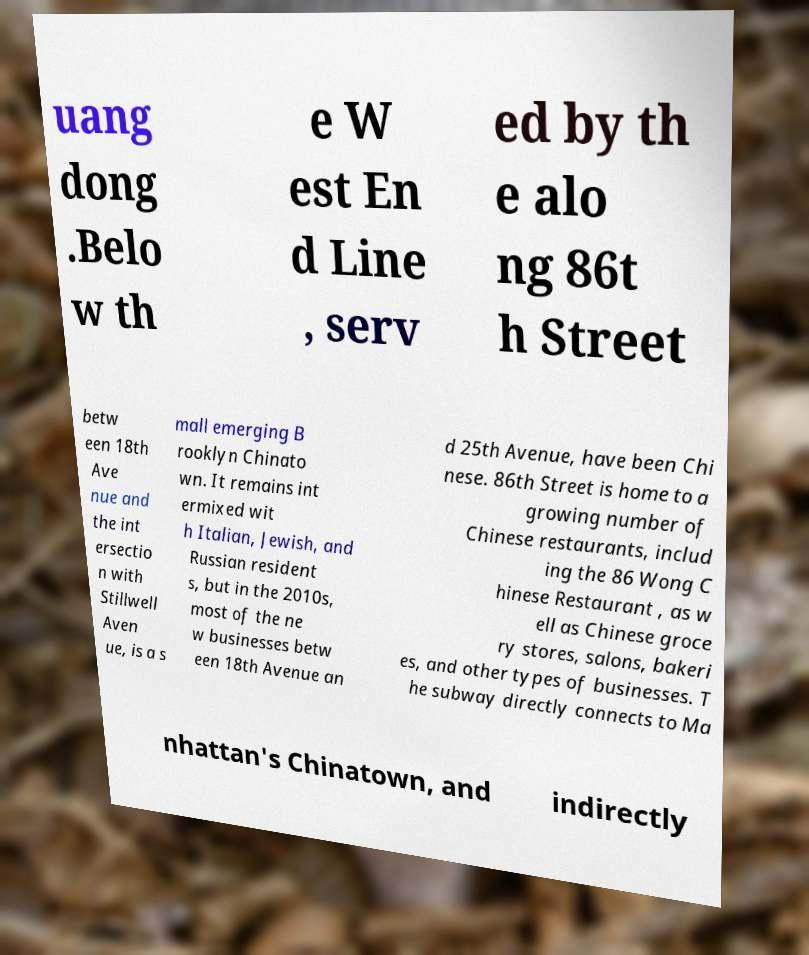I need the written content from this picture converted into text. Can you do that? uang dong .Belo w th e W est En d Line , serv ed by th e alo ng 86t h Street betw een 18th Ave nue and the int ersectio n with Stillwell Aven ue, is a s mall emerging B rooklyn Chinato wn. It remains int ermixed wit h Italian, Jewish, and Russian resident s, but in the 2010s, most of the ne w businesses betw een 18th Avenue an d 25th Avenue, have been Chi nese. 86th Street is home to a growing number of Chinese restaurants, includ ing the 86 Wong C hinese Restaurant , as w ell as Chinese groce ry stores, salons, bakeri es, and other types of businesses. T he subway directly connects to Ma nhattan's Chinatown, and indirectly 